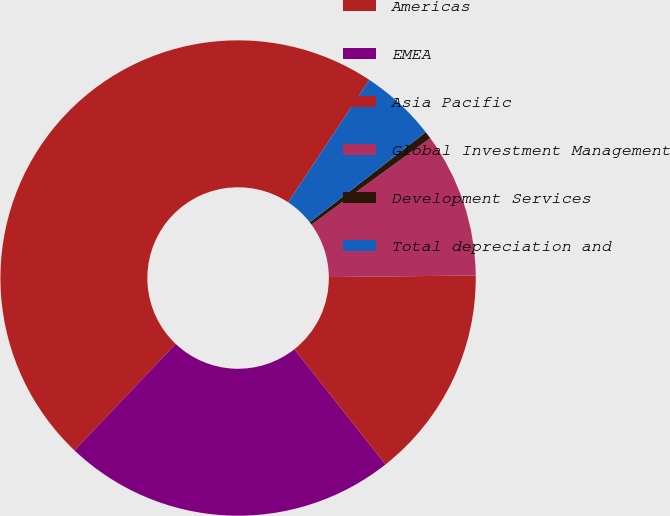Convert chart. <chart><loc_0><loc_0><loc_500><loc_500><pie_chart><fcel>Americas<fcel>EMEA<fcel>Asia Pacific<fcel>Global Investment Management<fcel>Development Services<fcel>Total depreciation and<nl><fcel>47.23%<fcel>22.73%<fcel>14.52%<fcel>9.85%<fcel>0.5%<fcel>5.17%<nl></chart> 